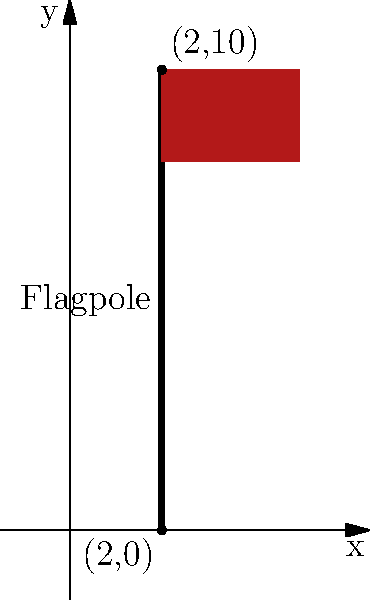A flagpole stands tall and proud, symbolizing the honor and sacrifice of our nation's veterans. The base of the flagpole is located at coordinates (2,0), and the top of the flagpole reaches coordinates (2,10) on a coordinate plane. Calculate the slope of the line representing this flagpole. What does this slope indicate about the flagpole's position? Let's approach this step-by-step:

1) The slope of a line can be calculated using the formula:

   $$ m = \frac{y_2 - y_1}{x_2 - x_1} $$

   where $(x_1, y_1)$ and $(x_2, y_2)$ are two points on the line.

2) In this case, we have:
   - Point at the base: $(x_1, y_1) = (2, 0)$
   - Point at the top: $(x_2, y_2) = (2, 10)$

3) Let's plug these values into our slope formula:

   $$ m = \frac{10 - 0}{2 - 2} = \frac{10}{0} $$

4) Mathematically, division by zero is undefined. In the context of slopes, this result has a special meaning.

5) When the denominator (change in x) is zero, it means there is no horizontal change between the two points. The line is perfectly vertical.

6) In geometry, a vertical line is said to have an undefined slope, or sometimes we say the slope is infinite.

7) This makes sense for a flagpole, which stands perfectly upright, parallel to the y-axis.
Answer: Undefined (vertical line) 